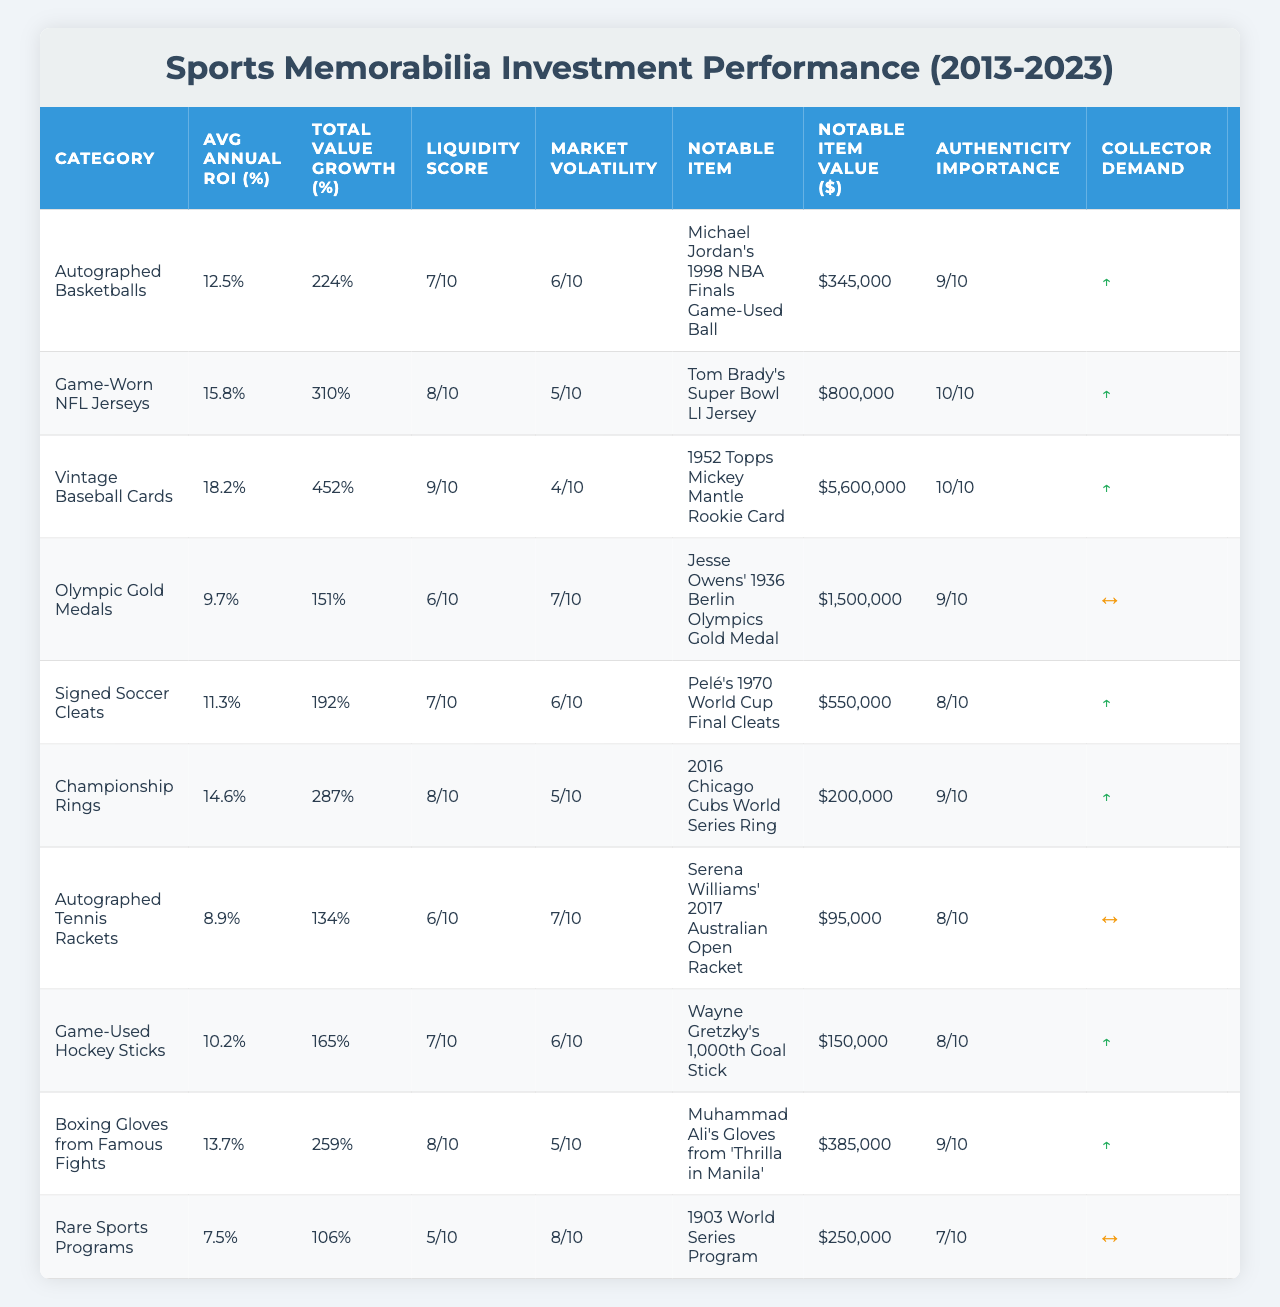What is the average annual ROI for Vintage Baseball Cards? The table shows that the Average Annual ROI for Vintage Baseball Cards is listed under the respective column. The value is 18.2%.
Answer: 18.2% Which category has the highest total value growth from 2013 to 2023? By examining the Total Value Growth column, Vintage Baseball Cards has the highest percentage at 452%.
Answer: 452% Is the liquidity score for Game-Worn NFL Jerseys higher than that for Autographed Tennis Rackets? The Liquidity Score for Game-Worn NFL Jerseys is 8, while the score for Autographed Tennis Rackets is 6. Since 8 is greater than 6, the statement is true.
Answer: Yes How many categories have a notable item value over $1 million? The notable item values exceeding $1 million are for 4 categories: Game-Worn NFL Jerseys, Vintage Baseball Cards, Olympic Gold Medals, and Championship Rings.
Answer: 4 What is the average liquidity score for all the sports memorabilia categories? To calculate the average, sum the liquidity scores (7 + 8 + 9 + 6 + 7 + 8 + 6 + 7 + 8 + 5 = 71) and divide by the number of categories (10). The average liquidity score is 71/10 = 7.1.
Answer: 7.1 Does the Collector Demand Trend for Game-Used Hockey Sticks indicate it is stable? The Collector Demand Trend for Game-Used Hockey Sticks is marked with "↑," indicating that demand is increasing, not stable, making this statement false.
Answer: No Which category has both the lowest average annual ROI and the lowest notable item value? Autographed Tennis Rackets have the lowest average annual ROI of 8.9% and a notable item value of $95,000, which are the lowest values in their respective categories.
Answer: Autographed Tennis Rackets What is the total value growth percentage for Signed Soccer Cleats compared to Championship Rings? Total Value Growth for Signed Soccer Cleats is 192%, and for Championship Rings is 287%. The difference is 287% - 192% = 95%, indicating that Championship Rings have a higher growth percentage.
Answer: 95% Which memorabilia category has the highest authenticity importance? By checking the Authenticity Importance column, both Vintage Baseball Cards and Game-Worn NFL Jerseys hold the highest score of 10.
Answer: Game-Worn NFL Jerseys, Vintage Baseball Cards What is the average storage cost as a percentage of value across all categories? The storage costs are 0.5%, 0.7%, 0.3%, 0.4%, 0.6%, 0.2%, 0.5%, 0.6%, 0.5%, and 0.4%. Adding them up (0.5 + 0.7 + 0.3 + 0.4 + 0.6 + 0.2 + 0.5 + 0.6 + 0.5 + 0.4 = 5.3) and dividing by 10 gives an average of 5.3% / 10 = 0.53%.
Answer: 0.53% 